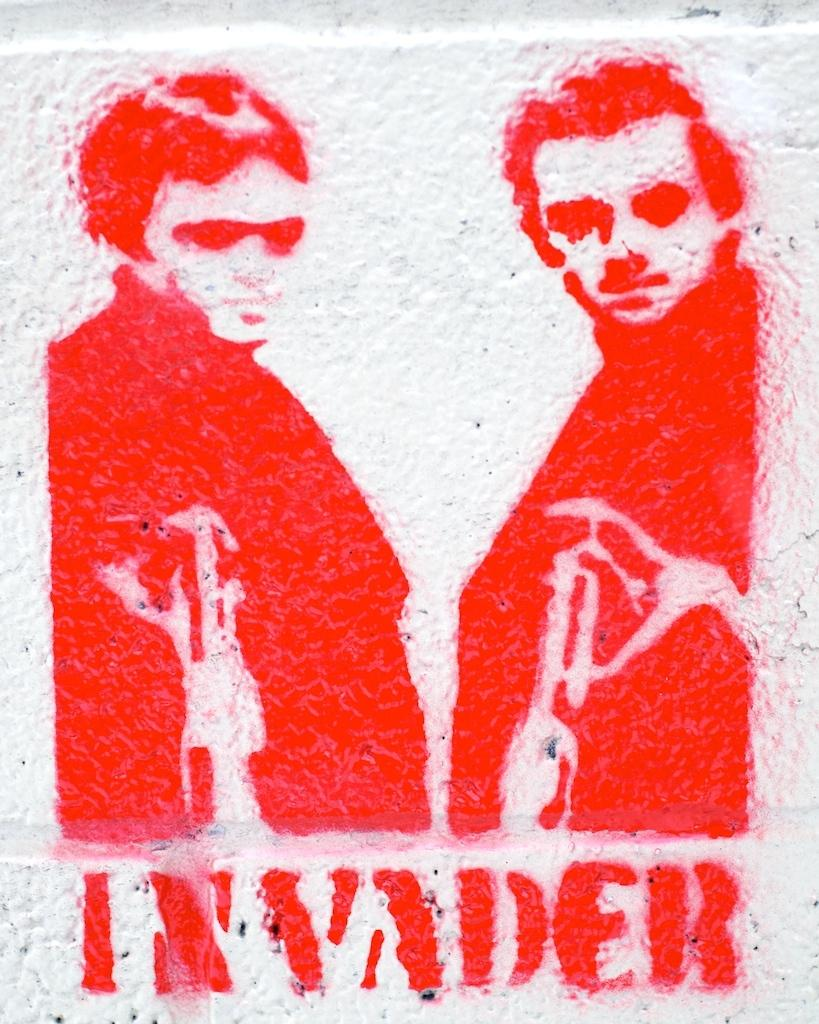What is the main subject of the image? The main subject of the image is an art piece. What does the art piece depict? The art piece depicts persons. Are there any additional elements in the art piece besides the depiction of persons? Yes, the art piece includes some text. What type of plant can be seen growing in the art piece? There is no plant visible in the art piece; it depicts persons and includes some text. 